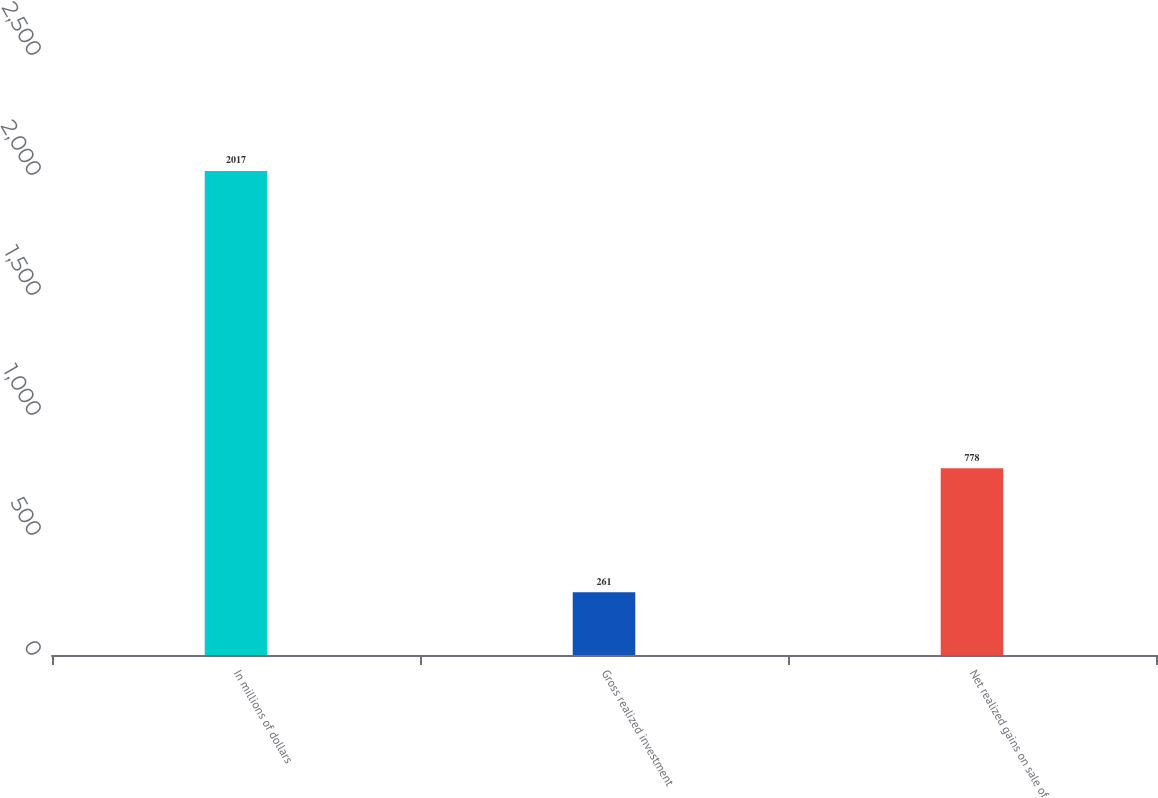<chart> <loc_0><loc_0><loc_500><loc_500><bar_chart><fcel>In millions of dollars<fcel>Gross realized investment<fcel>Net realized gains on sale of<nl><fcel>2017<fcel>261<fcel>778<nl></chart> 